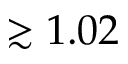Convert formula to latex. <formula><loc_0><loc_0><loc_500><loc_500>\gtrsim 1 . 0 2</formula> 